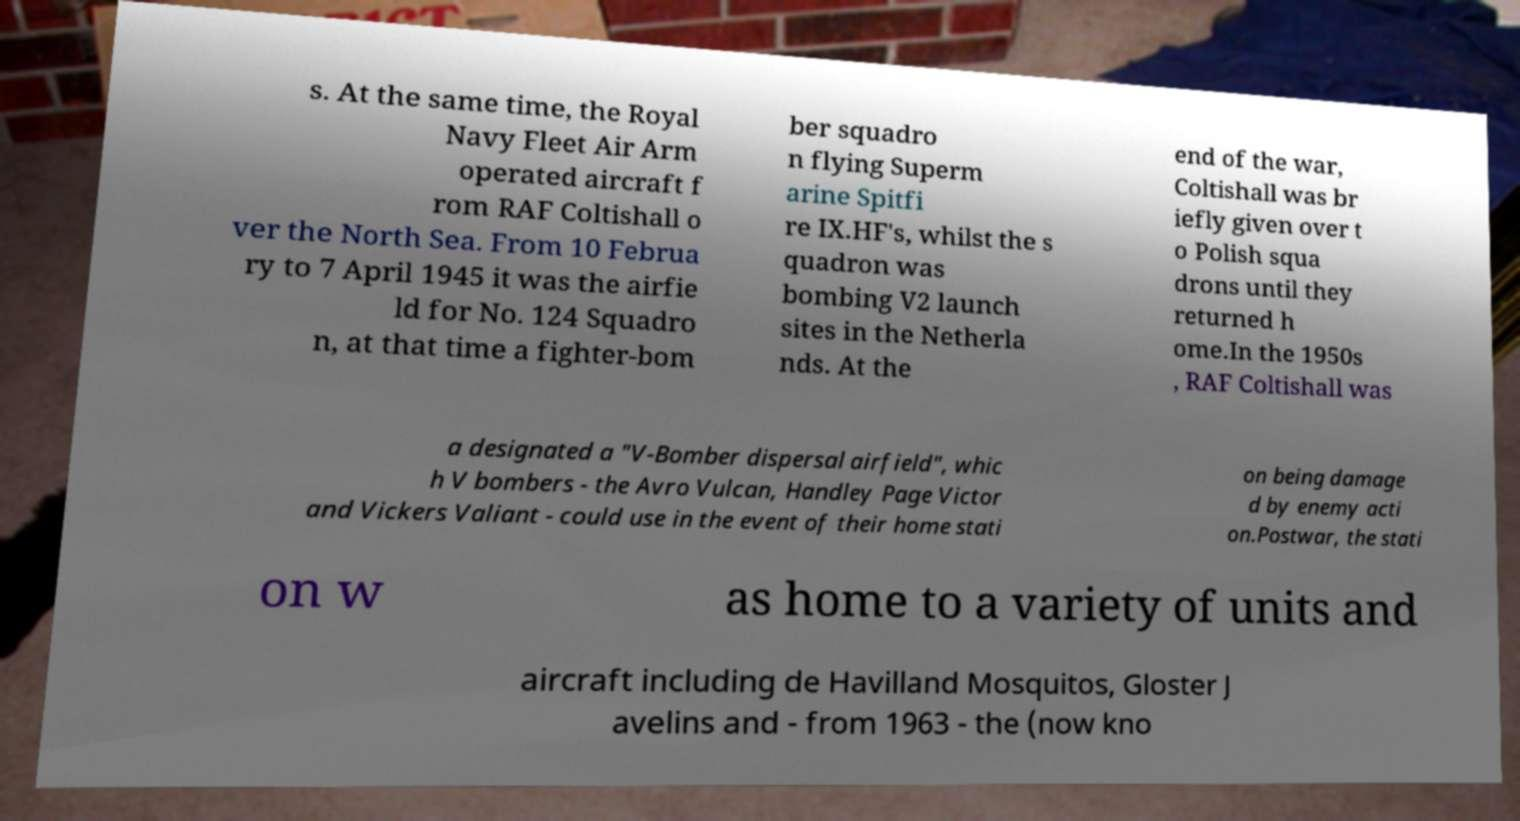Please read and relay the text visible in this image. What does it say? s. At the same time, the Royal Navy Fleet Air Arm operated aircraft f rom RAF Coltishall o ver the North Sea. From 10 Februa ry to 7 April 1945 it was the airfie ld for No. 124 Squadro n, at that time a fighter-bom ber squadro n flying Superm arine Spitfi re IX.HF's, whilst the s quadron was bombing V2 launch sites in the Netherla nds. At the end of the war, Coltishall was br iefly given over t o Polish squa drons until they returned h ome.In the 1950s , RAF Coltishall was a designated a "V-Bomber dispersal airfield", whic h V bombers - the Avro Vulcan, Handley Page Victor and Vickers Valiant - could use in the event of their home stati on being damage d by enemy acti on.Postwar, the stati on w as home to a variety of units and aircraft including de Havilland Mosquitos, Gloster J avelins and - from 1963 - the (now kno 